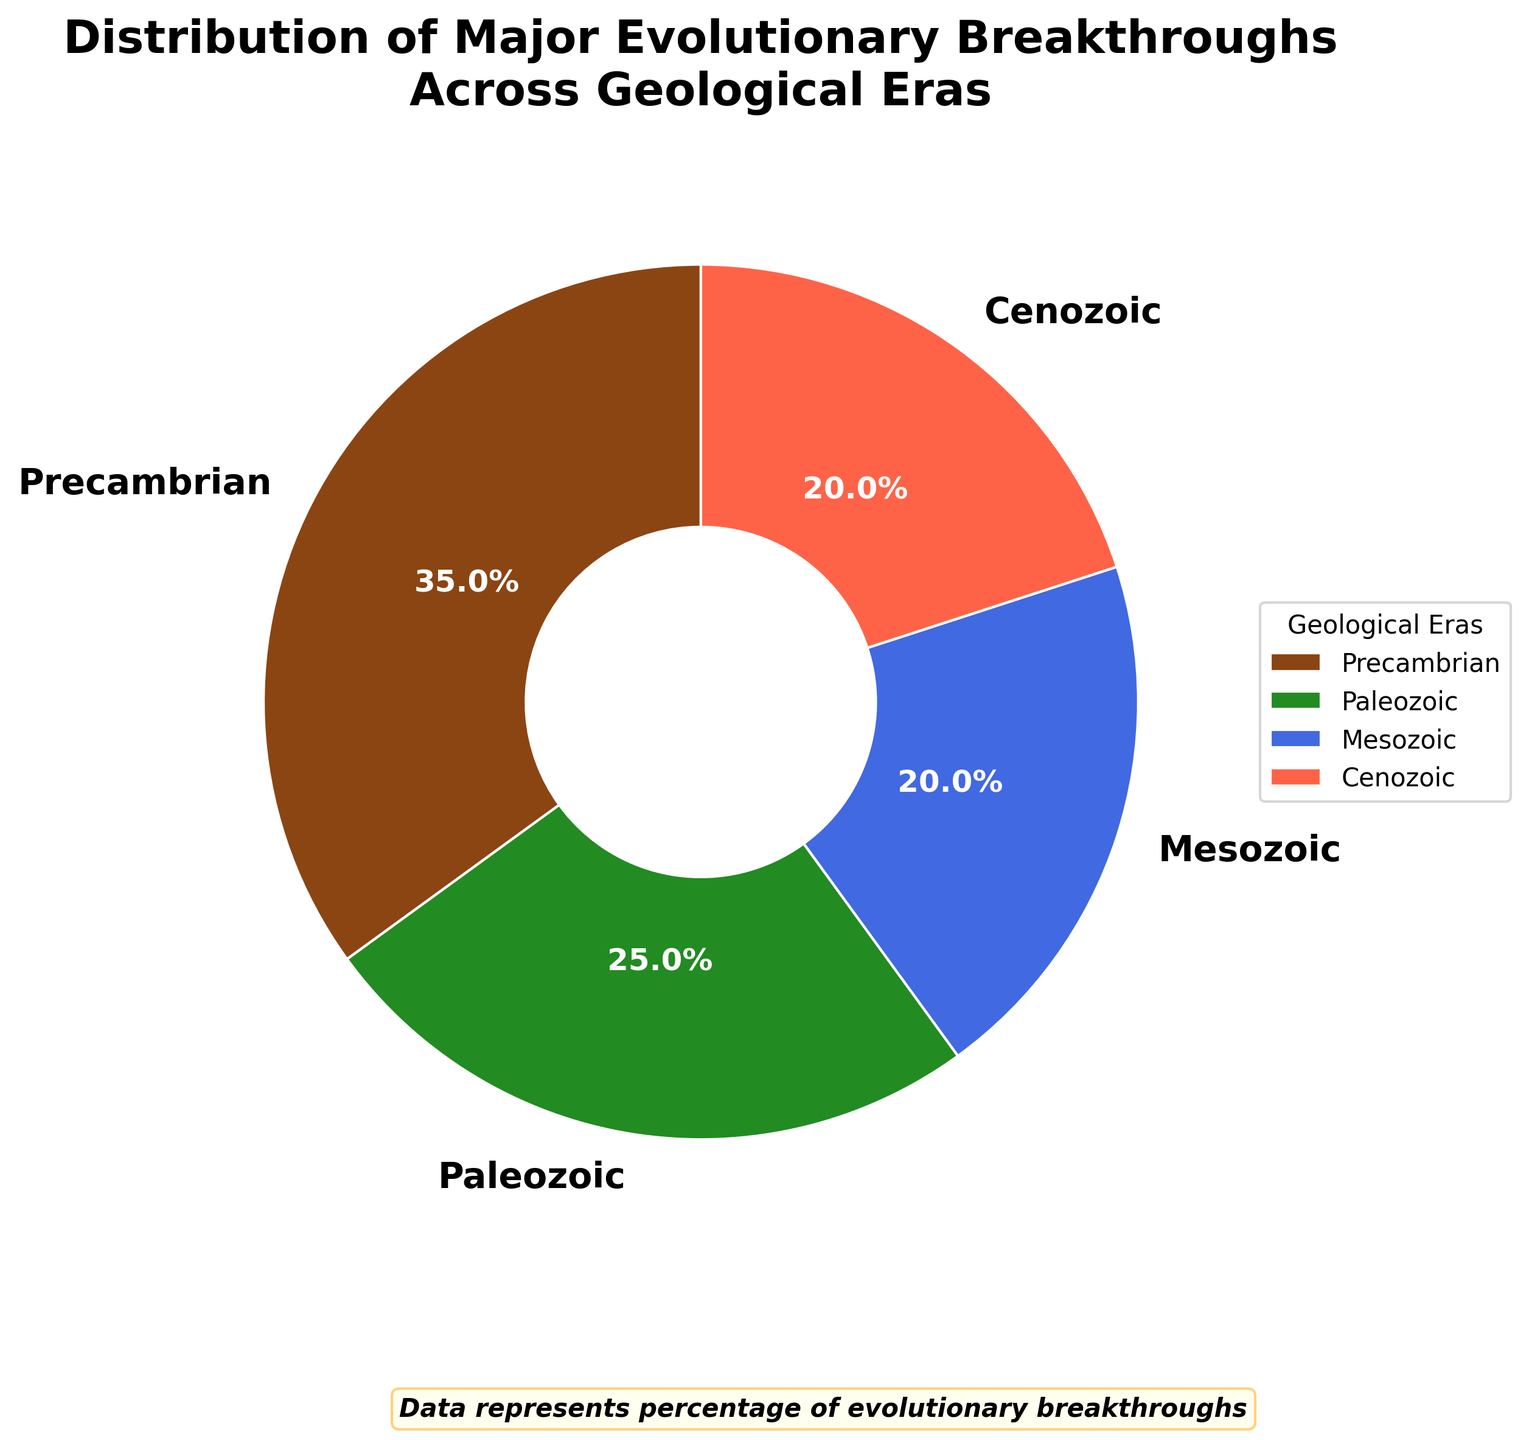What's the largest section on the pie chart? The pie chart displays four geological eras. By comparing the sizes, we see that the "Precambrian" era is the largest section.
Answer: Precambrian How much larger is the Precambrian era's percentage compared to the Paleozoic era's? The percentage for Precambrian is 35%, and for the Paleozoic, it's 25%. The difference is 35% - 25%.
Answer: 10% Which two eras share the same percentage distribution? By examining the pie chart's labels, we see that both the Mesozoic and Cenozoic eras have the same percentage.
Answer: Mesozoic and Cenozoic What is the total percentage of evolutionary breakthroughs that occurred in the Mesozoic and Cenozoic eras combined? The percentage for both the Mesozoic and Cenozoic is 20% each. Adding them together gives 20% + 20%.
Answer: 40% Which era has the least number of major evolutionary breakthroughs? Looking at the pie chart's labels, the Mesozoic and Cenozoic both have 20%, but since they are equal and no other era is less, they both tie for the least.
Answer: Mesozoic and Cenozoic How many percentage points is the Paleozoic era larger than the Mesozoic era? The Paleozoic era has 25%, while the Mesozoic era has 20%. The difference is 25% - 20%.
Answer: 5% Compare the total percentage of breakthroughs in the Precambrian and Cenozoic eras to the total percentage of the Paleozoic era. Which is larger? The sum of the Precambrian and Cenozoic eras is 35% + 20% = 55%, while the Paleozoic era is 25%. 55% is larger than 25%.
Answer: Precambrian and Cenozoic What color represents the Paleozoic era in the pie chart? The pie chart uses colors to differentiate each era. The Paleozoic era is represented by the green section.
Answer: Green 